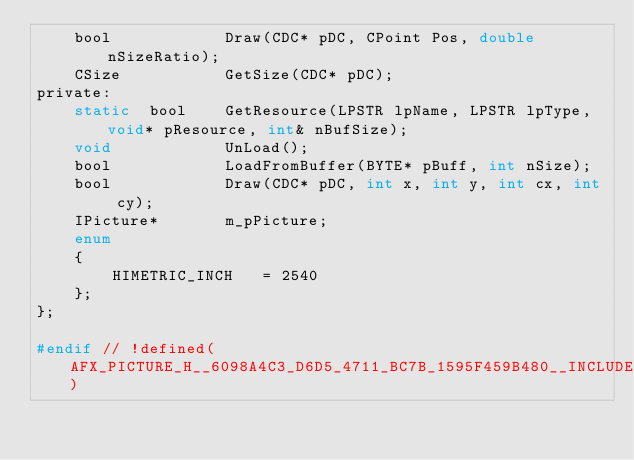Convert code to text. <code><loc_0><loc_0><loc_500><loc_500><_C_>	bool			Draw(CDC* pDC, CPoint Pos, double nSizeRatio);
	CSize			GetSize(CDC* pDC);
private:
	static	bool	GetResource(LPSTR lpName, LPSTR lpType, void* pResource, int& nBufSize);
	void			UnLoad();
	bool			LoadFromBuffer(BYTE* pBuff, int nSize);
	bool			Draw(CDC* pDC, int x, int y, int cx, int cy);
	IPicture*		m_pPicture;
	enum
	{
		HIMETRIC_INCH	= 2540
	};
};

#endif // !defined(AFX_PICTURE_H__6098A4C3_D6D5_4711_BC7B_1595F459B480__INCLUDED_)
</code> 